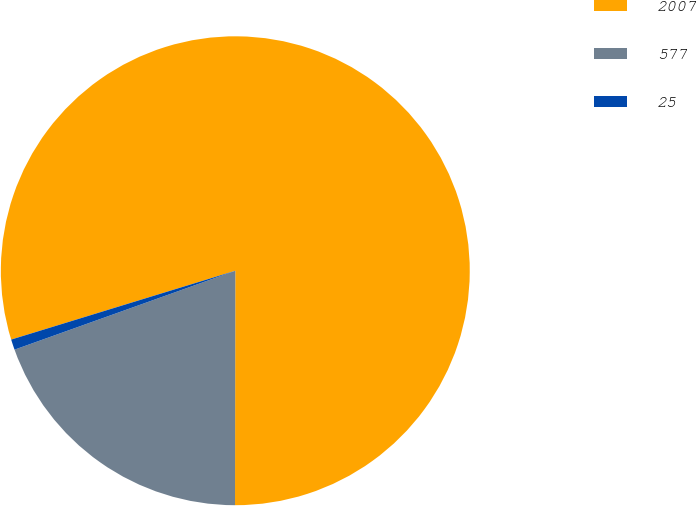<chart> <loc_0><loc_0><loc_500><loc_500><pie_chart><fcel>2007<fcel>577<fcel>25<nl><fcel>79.77%<fcel>19.52%<fcel>0.72%<nl></chart> 